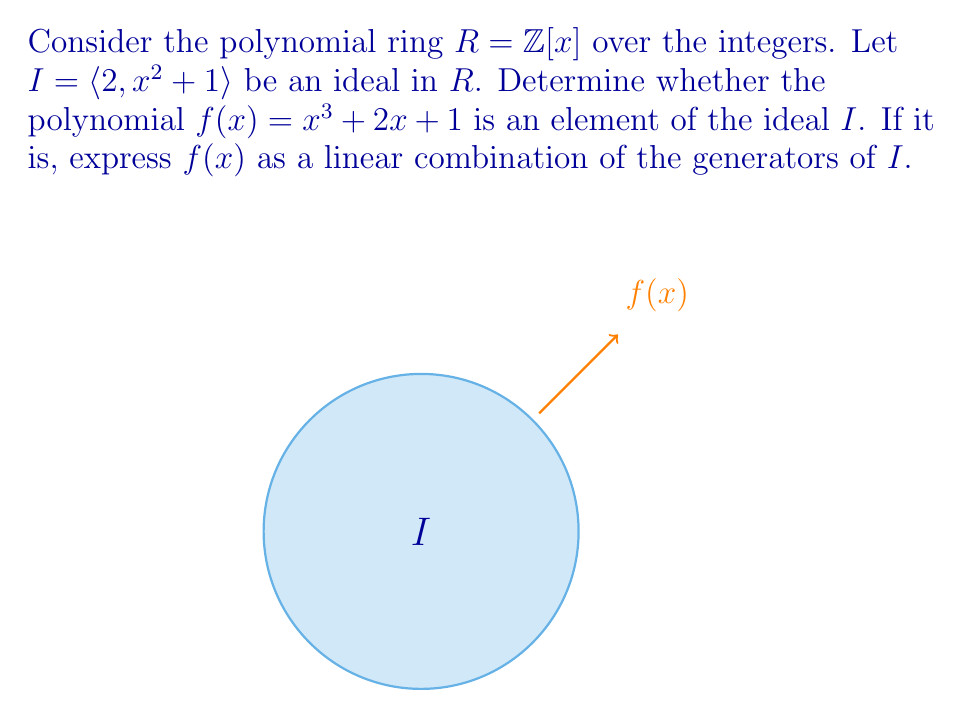Solve this math problem. Let's approach this step-by-step:

1) An element of the ideal $I = \langle 2, x^2 + 1 \rangle$ can be written as a linear combination of its generators:

   $a(x)(2) + b(x)(x^2 + 1)$, where $a(x), b(x) \in \mathbb{Z}[x]$

2) To check if $f(x) = x^3 + 2x + 1$ is in $I$, we need to find polynomials $a(x)$ and $b(x)$ that satisfy:

   $f(x) = 2a(x) + (x^2 + 1)b(x)$

3) Let's try to construct such polynomials:
   
   $x^3 + 2x + 1 = (x^2 + 1)(x) + (2x + 1)$

4) Now we can write:
   
   $2x + 1 = 2(x) + 1 = 2(x) + (x^2 + 1) - x^2$
   
   $= 2(x) + (x^2 + 1)(1) - x^2$
   
   $= 2(x) + (x^2 + 1)(1) - (x^2 + 1)(x) + x$
   
   $= 2(x + 1) + (x^2 + 1)(1 - x)$

5) Putting it all together:

   $x^3 + 2x + 1 = (x^2 + 1)(x) + 2(x + 1) + (x^2 + 1)(1 - x)$
   
   $= 2(x + 1) + (x^2 + 1)(1)$

6) Therefore, we have found $a(x) = x + 1$ and $b(x) = 1$ that satisfy the condition.

Thus, $f(x)$ is indeed an element of the ideal $I$, and we have expressed it as a linear combination of the generators.
Answer: $f(x) = 2(x+1) + (x^2+1)(1)$ 